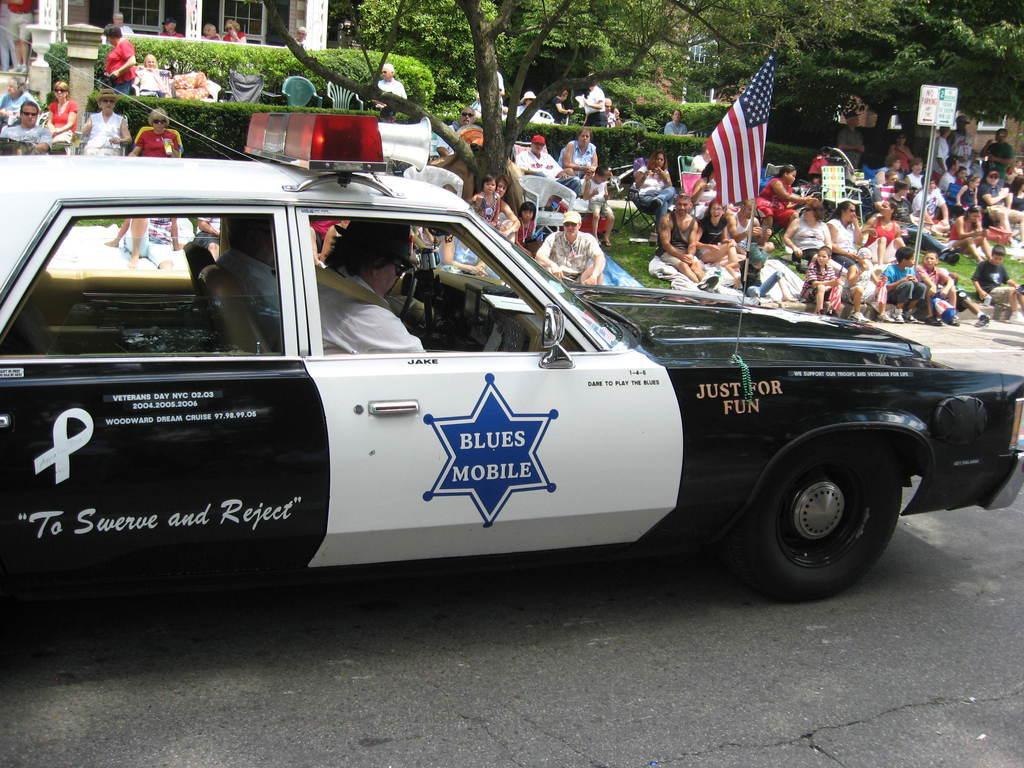Please provide a concise description of this image. In this image I can see a group of people are sitting on the ground. I can also see there is a car on the road. 